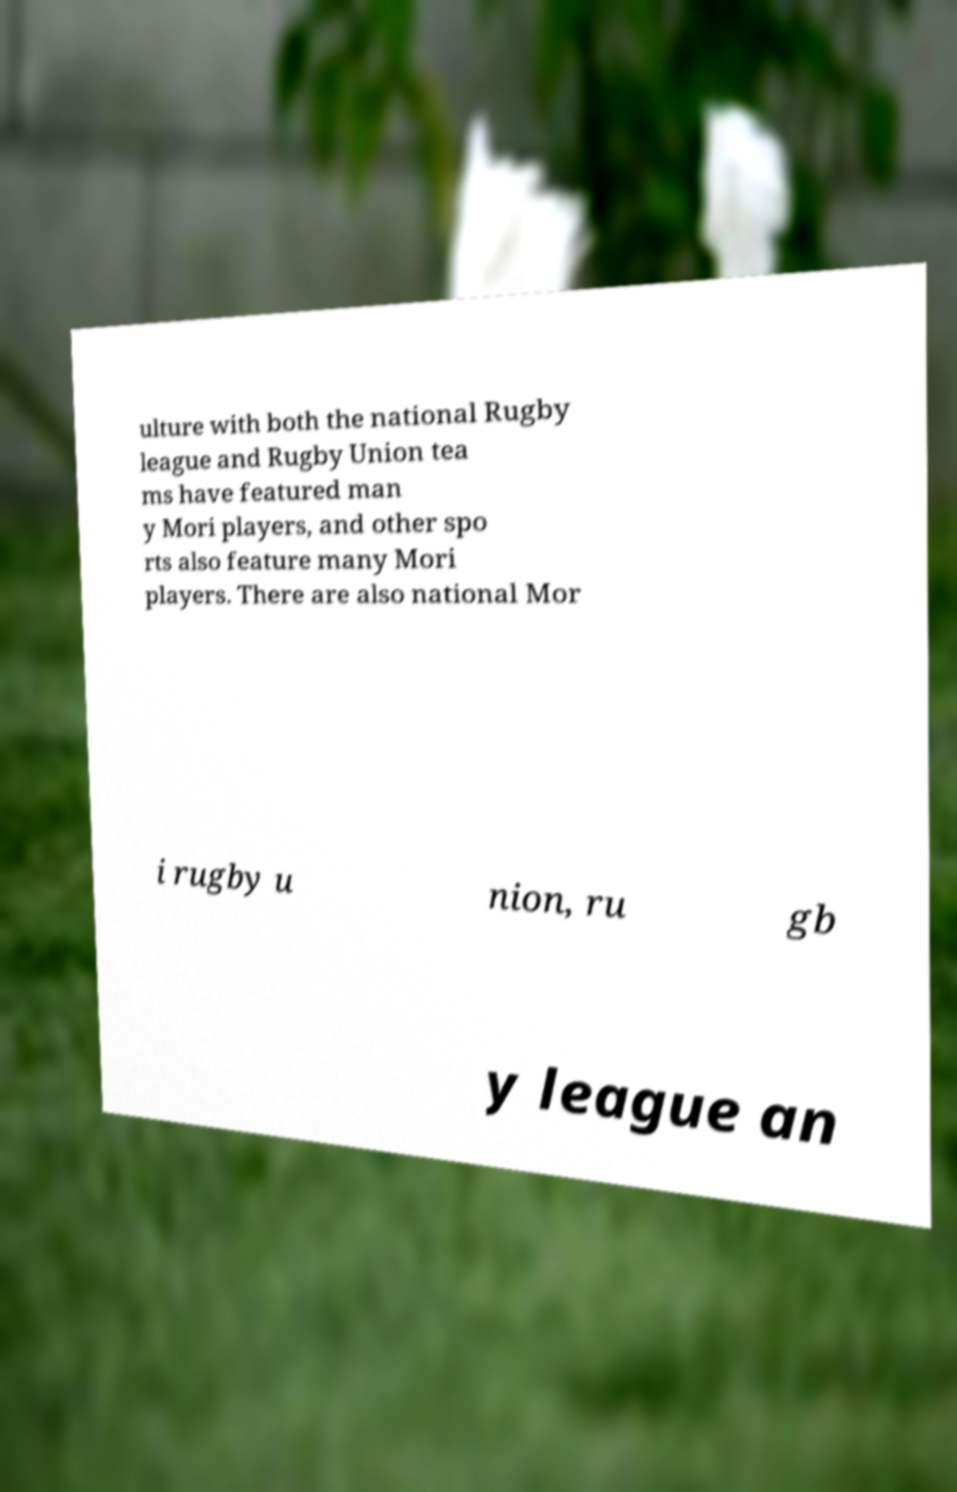I need the written content from this picture converted into text. Can you do that? ulture with both the national Rugby league and Rugby Union tea ms have featured man y Mori players, and other spo rts also feature many Mori players. There are also national Mor i rugby u nion, ru gb y league an 